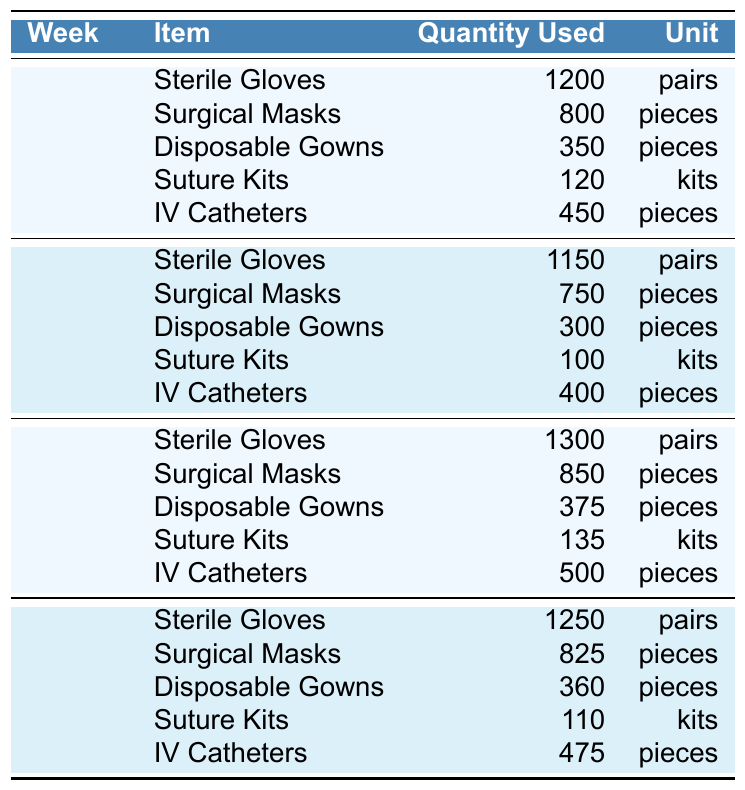What was the total quantity of Sterile Gloves used in Week 2? In Week 2, the table shows that 1150 pairs of Sterile Gloves were used. Thus, the total quantity is simply 1150.
Answer: 1150 pairs Which item had the lowest quantity used in Week 1? In Week 1, we compare the quantities of all items: Sterile Gloves (1200), Surgical Masks (800), Disposable Gowns (350), Suture Kits (120), and IV Catheters (450). The lowest quantity is 120 for Suture Kits.
Answer: Suture Kits What is the average quantity of Surgical Masks used over the four weeks? The quantities for Surgical Masks are: Week 1 (800), Week 2 (750), Week 3 (850), and Week 4 (825). Adding these gives 800 + 750 + 850 + 825 = 3225. Dividing by the number of weeks (4) results in an average of 3225/4 = 806.25.
Answer: 806.25 pieces Did the usage of Disposable Gowns increase or decrease from Week 3 to Week 4? The usage of Disposable Gowns in Week 3 is 375 pieces, and in Week 4, it is 360 pieces. Since 360 is less than 375, this indicates a decrease.
Answer: Decrease What is the total quantity of IV Catheters used in Week 1 and Week 3 combined? In Week 1, 450 pieces of IV Catheters were used, and in Week 3, 500 pieces were used. Adding these two quantities gives 450 + 500 = 950.
Answer: 950 pieces Which week had the highest usage of Suture Kits, and how many were used? Checking the Suture Kit usage across the weeks, we see: Week 1 (120), Week 2 (100), Week 3 (135), and Week 4 (110). The highest was in Week 3 with 135 kits used.
Answer: Week 3, 135 kits Is it true that more Sterile Gloves were used in Week 4 than in Week 2? The quantities are 1250 pairs for Week 4 and 1150 pairs for Week 2. Since 1250 is greater than 1150, this statement is true.
Answer: Yes What was the total quantity of Disposable Gowns used over all four weeks? Summing up the quantities: Week 1 (350), Week 2 (300), Week 3 (375), and Week 4 (360) gives 350 + 300 + 375 + 360 = 1385.
Answer: 1385 pieces How many more Surgical Masks were used in Week 1 compared to Week 4? In Week 1, 800 Surgical Masks were used, and in Week 4, 825 were used. The difference is 800 - 825 = -25, indicating there were more used in Week 4 than Week 1.
Answer: More in Week 4 What is the difference in the quantity of IV Catheters used between Week 2 and Week 3? In Week 2, 400 IV Catheters were used, and in Week 3, 500 were used. The difference is 500 - 400 = 100, indicating an increase of 100 in Week 3.
Answer: 100 more in Week 3 